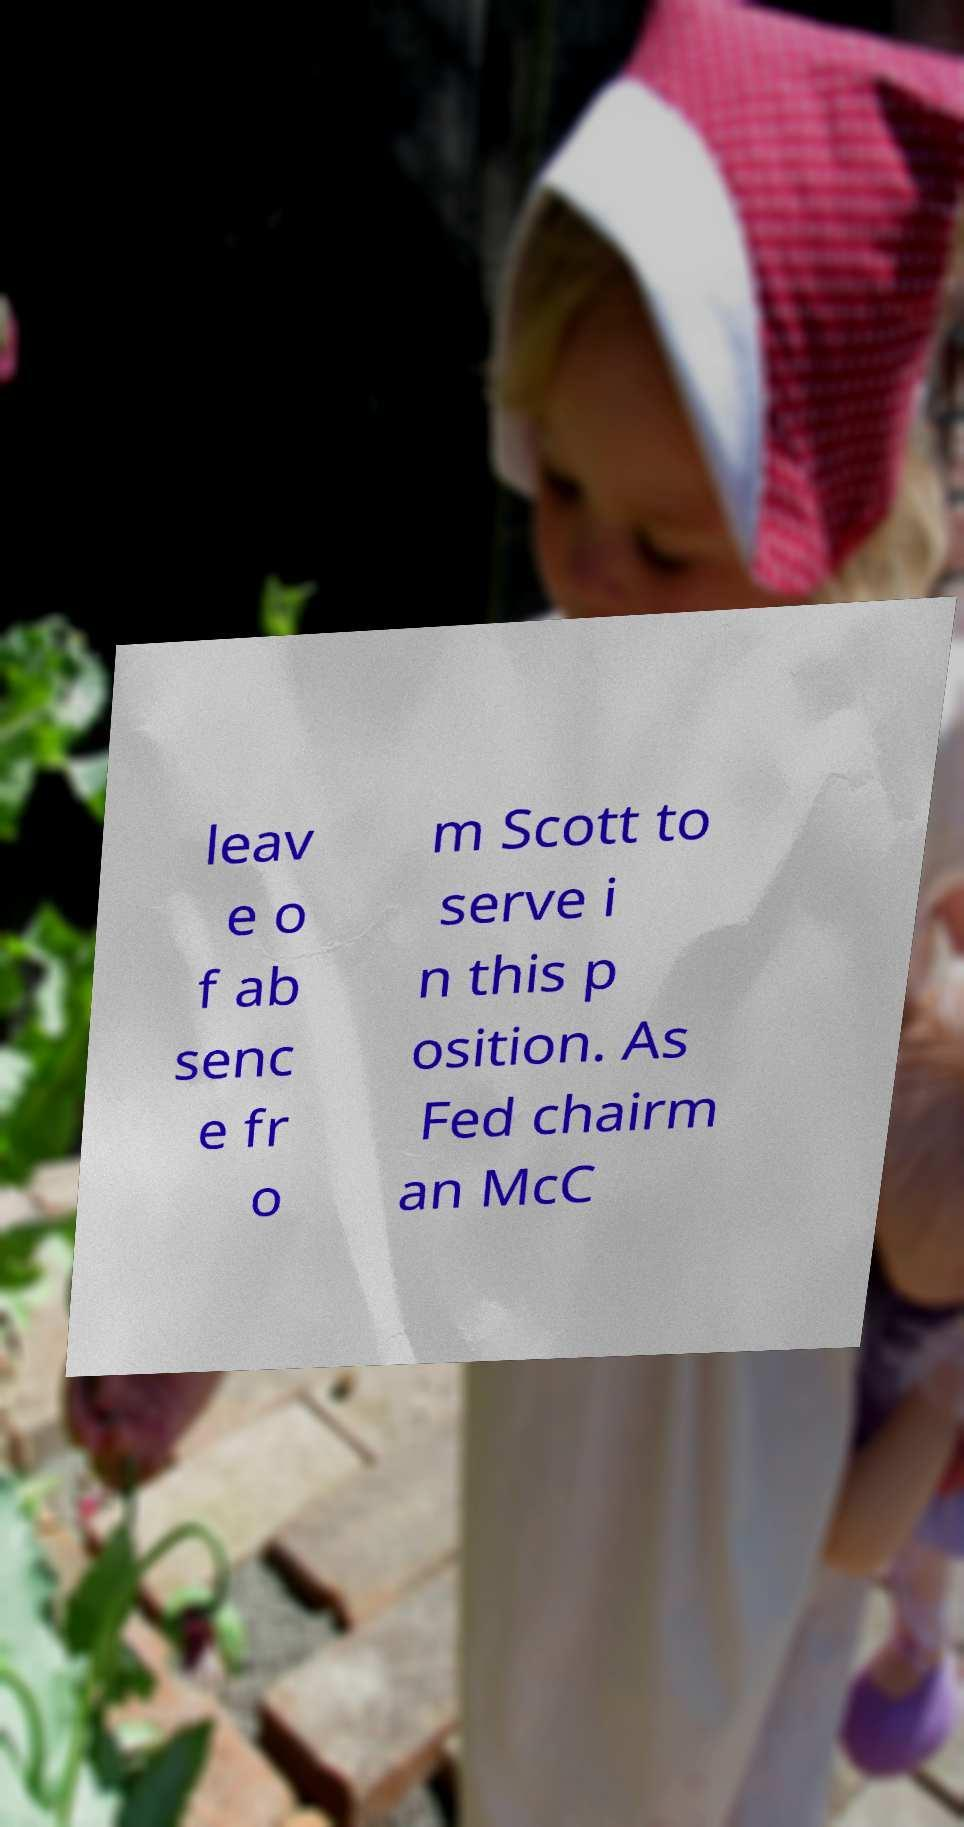Please read and relay the text visible in this image. What does it say? leav e o f ab senc e fr o m Scott to serve i n this p osition. As Fed chairm an McC 